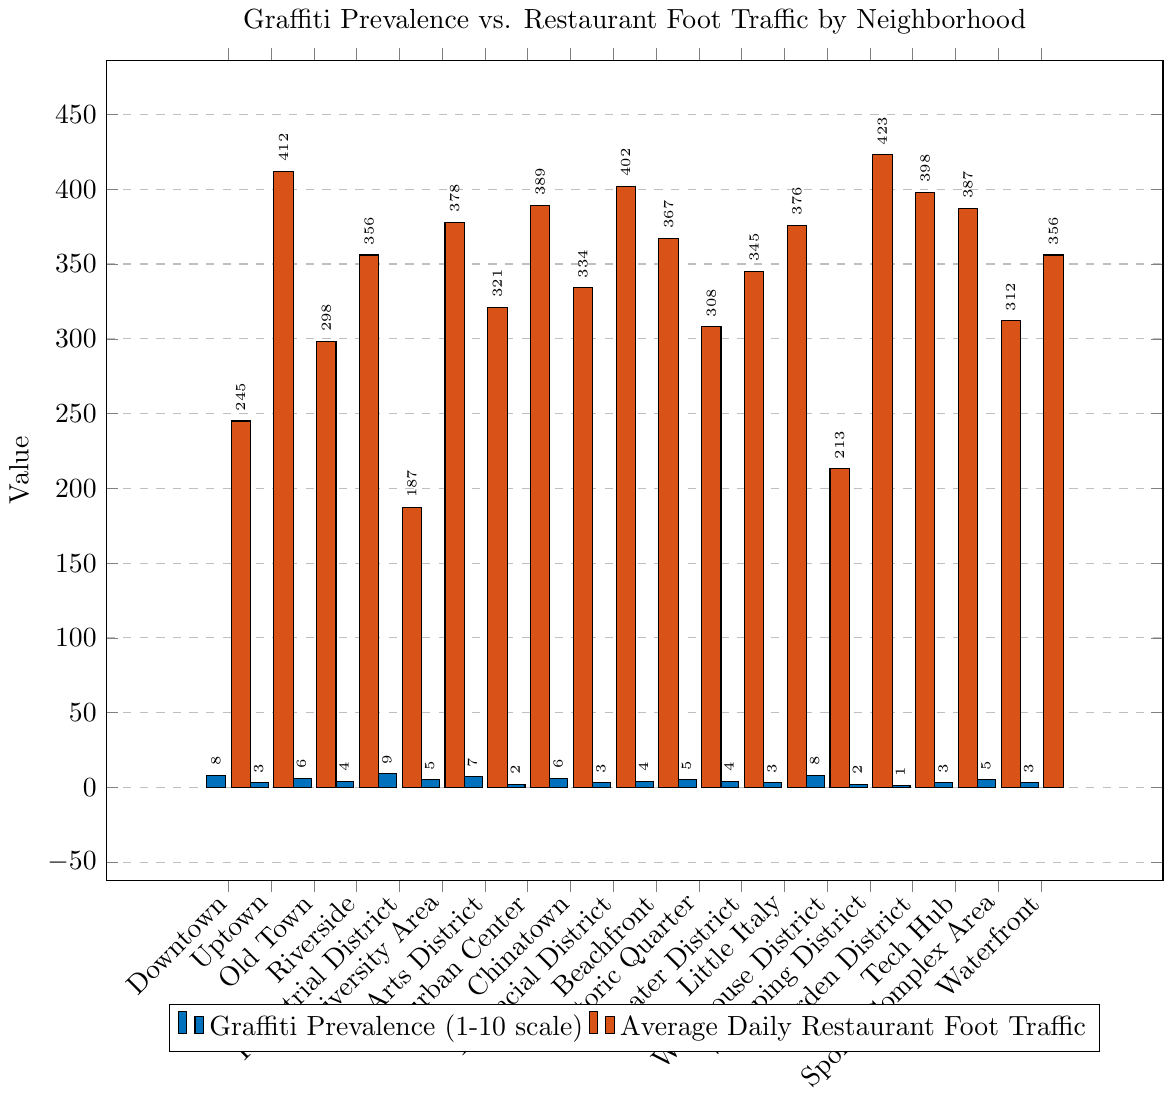What neighborhood has the highest graffiti prevalence? The tallest blue bar represents the neighborhood with the highest graffiti prevalence, which is the Industrial District.
Answer: Industrial District Which neighborhood experiences the highest average daily restaurant foot traffic? The tallest red bar indicates the neighborhood with the highest average daily restaurant foot traffic, which is the Uptown neighborhood.
Answer: Uptown Is there a trend between graffiti prevalence and restaurant foot traffic? Reviewing the bars, it is observed that neighborhoods with higher graffiti prevalence, like Downtown and Industrial District, tend to have lower foot traffic compared to those with lower graffiti prevalence, like Uptown and who have higher foot traffic.
Answer: Higher graffiti prevalence tends to correlate with lower foot traffic Which neighborhoods have a graffiti prevalence of 6? By looking at the height of the blue bars, the neighborhoods with a graffiti prevalence of 6 are Old Town and Chinatown.
Answer: Old Town, Chinatown What is the difference in average daily restaurant foot traffic between Uptown and Downtown? Uptown has a red bar of height 412, and Downtown's red bar has a height of 245. The difference is 412 - 245 = 167.
Answer: 167 For the neighborhoods with a graffiti prevalence of 2, what is their average daily restaurant foot traffic? The neighborhoods with a graffiti prevalence of 2 are Suburban Center and Shopping District, with average daily foot traffic of 389 and 423 respectively. The average is (389 + 423)/2 = 406.
Answer: 406 Which neighborhood has both relatively low graffiti prevalence and high foot traffic? Suburban Center has a low graffiti prevalence (blue bar of height 2) and relatively high foot traffic (red bar of height 389).
Answer: Suburban Center Is Chinatown's restaurant foot traffic higher or lower than the average foot traffic of neighborhoods with a graffiti prevalence of 6? Chinatown has a foot traffic of 334. Other neighborhoods with graffiti prevalence of 6 are Old Town (foot traffic 298). The average foot traffic is (298 + 334)/2 = 316. As 334 > 316, Chinatown's foot traffic is higher.
Answer: Higher Which neighborhood has the highest graffiti prevalence and what is its corresponding foot traffic? The highest graffiti prevalence is in the Industrial District (blue bar of height 9) with an average daily restaurant foot traffic of 187.
Answer: Industrial District, 187 